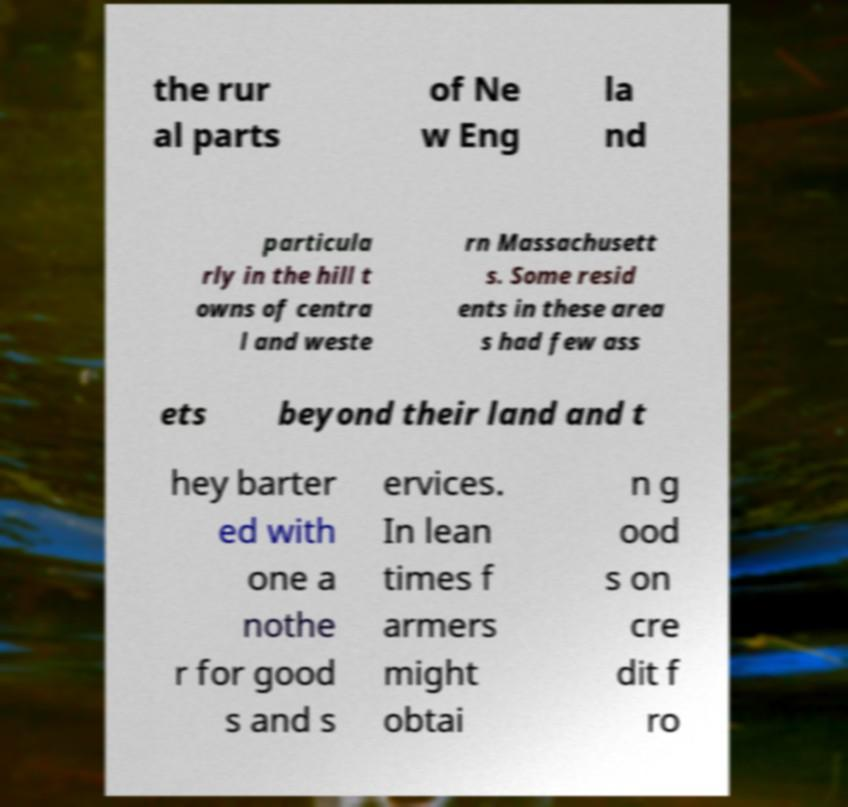For documentation purposes, I need the text within this image transcribed. Could you provide that? the rur al parts of Ne w Eng la nd particula rly in the hill t owns of centra l and weste rn Massachusett s. Some resid ents in these area s had few ass ets beyond their land and t hey barter ed with one a nothe r for good s and s ervices. In lean times f armers might obtai n g ood s on cre dit f ro 